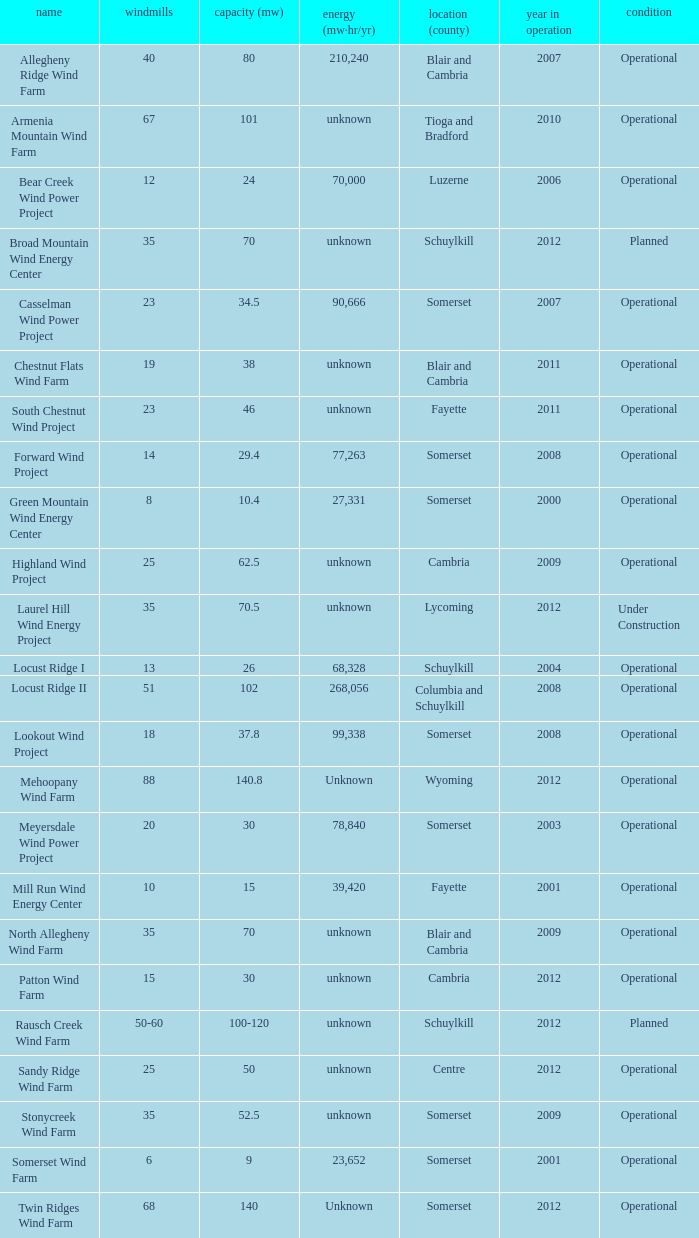What year was Fayette operational at 46? 2011.0. 